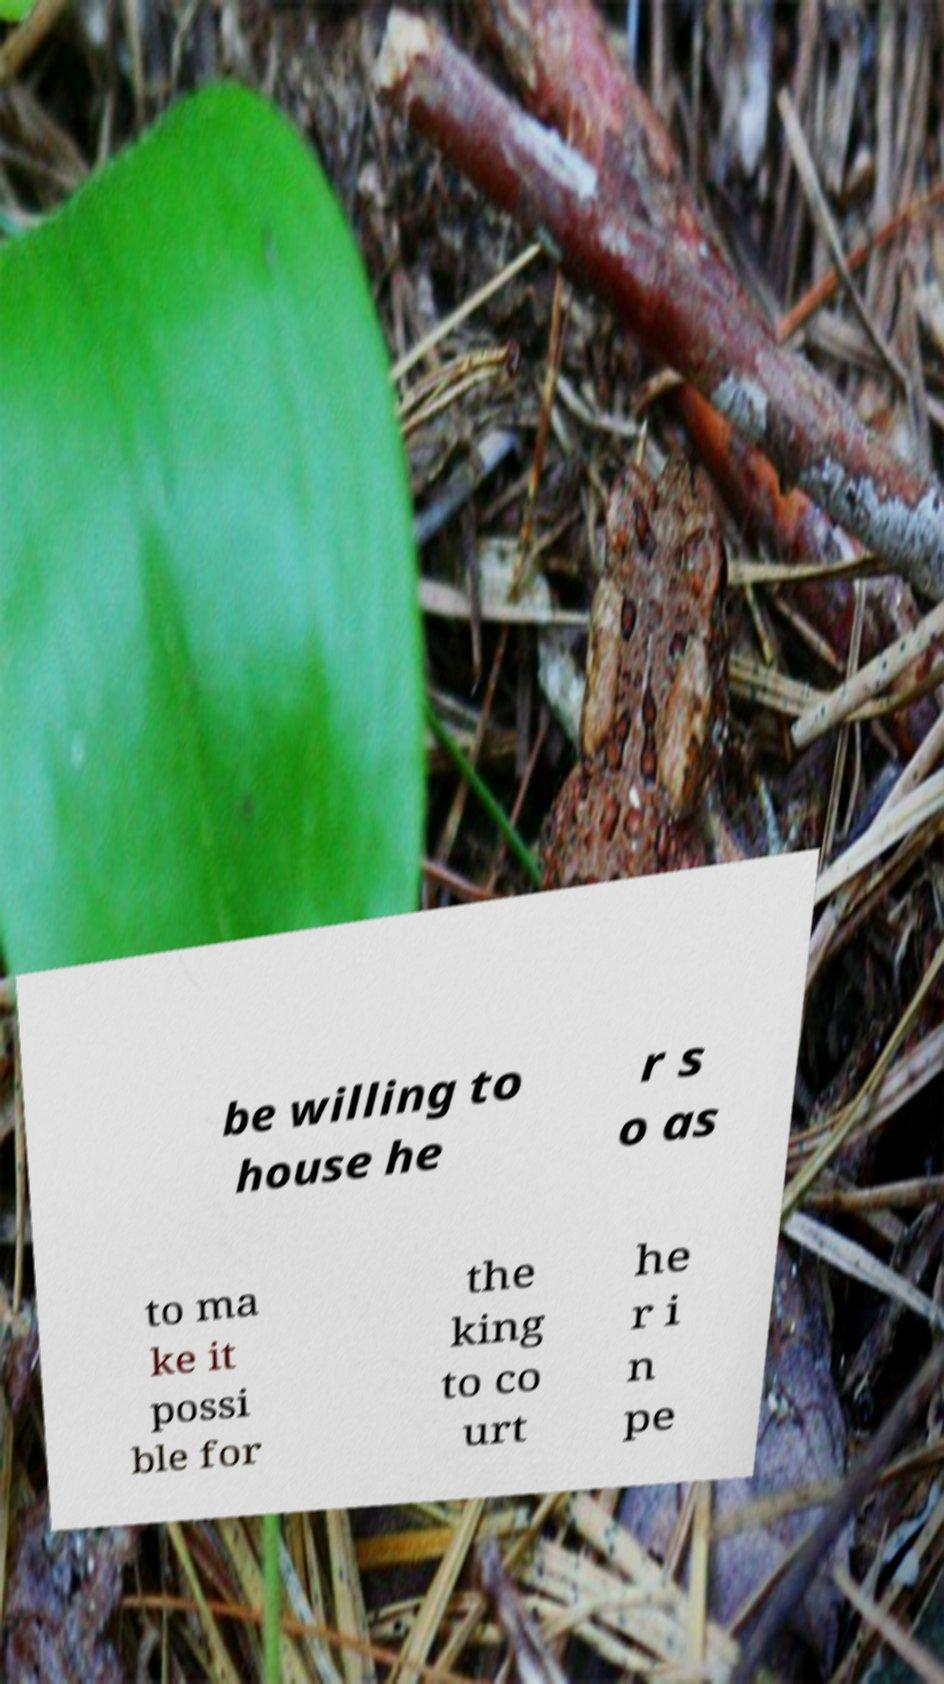Could you extract and type out the text from this image? be willing to house he r s o as to ma ke it possi ble for the king to co urt he r i n pe 